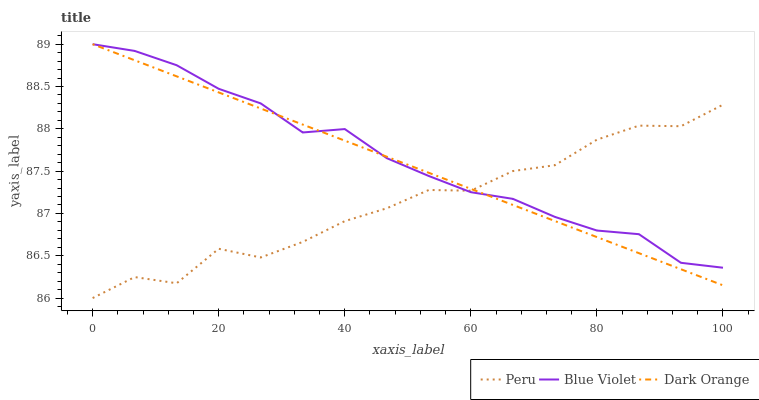Does Blue Violet have the minimum area under the curve?
Answer yes or no. No. Does Peru have the maximum area under the curve?
Answer yes or no. No. Is Blue Violet the smoothest?
Answer yes or no. No. Is Blue Violet the roughest?
Answer yes or no. No. Does Blue Violet have the lowest value?
Answer yes or no. No. Does Peru have the highest value?
Answer yes or no. No. 